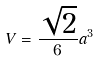Convert formula to latex. <formula><loc_0><loc_0><loc_500><loc_500>V = \frac { \sqrt { 2 } } { 6 } a ^ { 3 }</formula> 